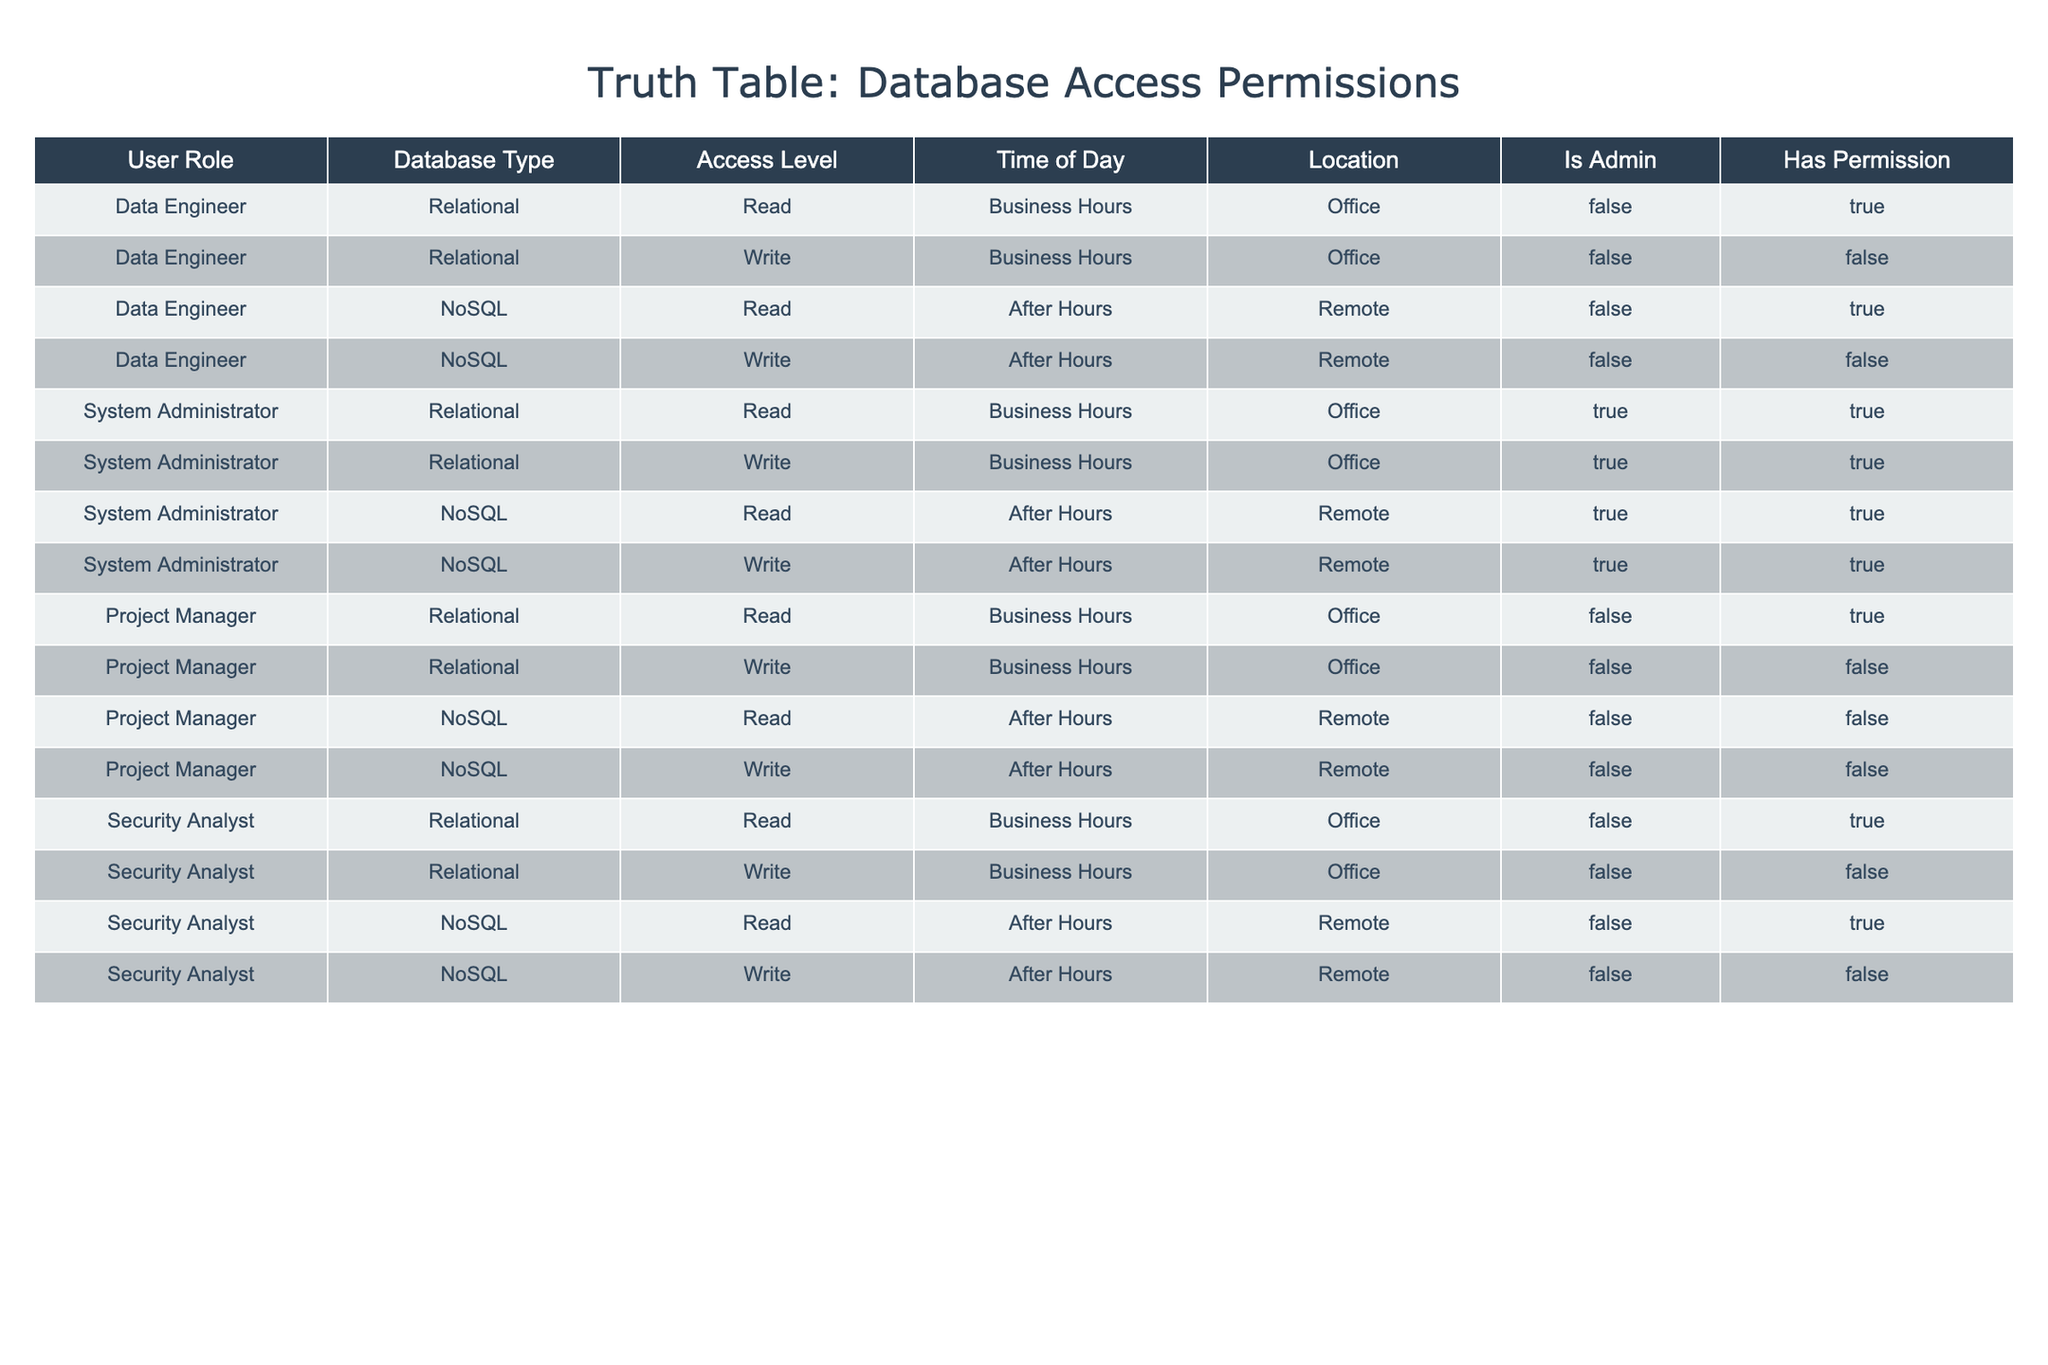What is the access level for a Data Engineer at the Office during Business Hours? According to the table, a Data Engineer at the Office during Business Hours has two access levels: "Read" and "Write." The "Read" access level is granted as per the third row. However, the "Write" access level is denied as seen in the fourth row.
Answer: Read Is it true that a System Administrator can write to a NoSQL database after hours? The table indicates that the System Administrator has "Write" permission for the NoSQL database after hours according to the eighth row, where "Has Permission" is marked as True.
Answer: True How many roles have permission to read a Relational database during Business Hours? The table shows four roles: Data Engineer, System Administrator, Project Manager, and Security Analyst. All four roles have the permission to read a Relational database during Business Hours, as indicated in their respective rows. Thus, the count is 4.
Answer: 4 What is the access level of a Security Analyst for NoSQL databases during After Hours? Referring to the table, for a Security Analyst accessing a NoSQL database after hours, the access level listed is "Read," and it is granted since "Has Permission" is True in the last row.
Answer: Read Is a Data Engineer able to write to a Relational database during Business Hours? The table demonstrates that a Data Engineer does not have permission to write to a Relational database during Business Hours, as the relevant row indicates "Has Permission" is False.
Answer: No 